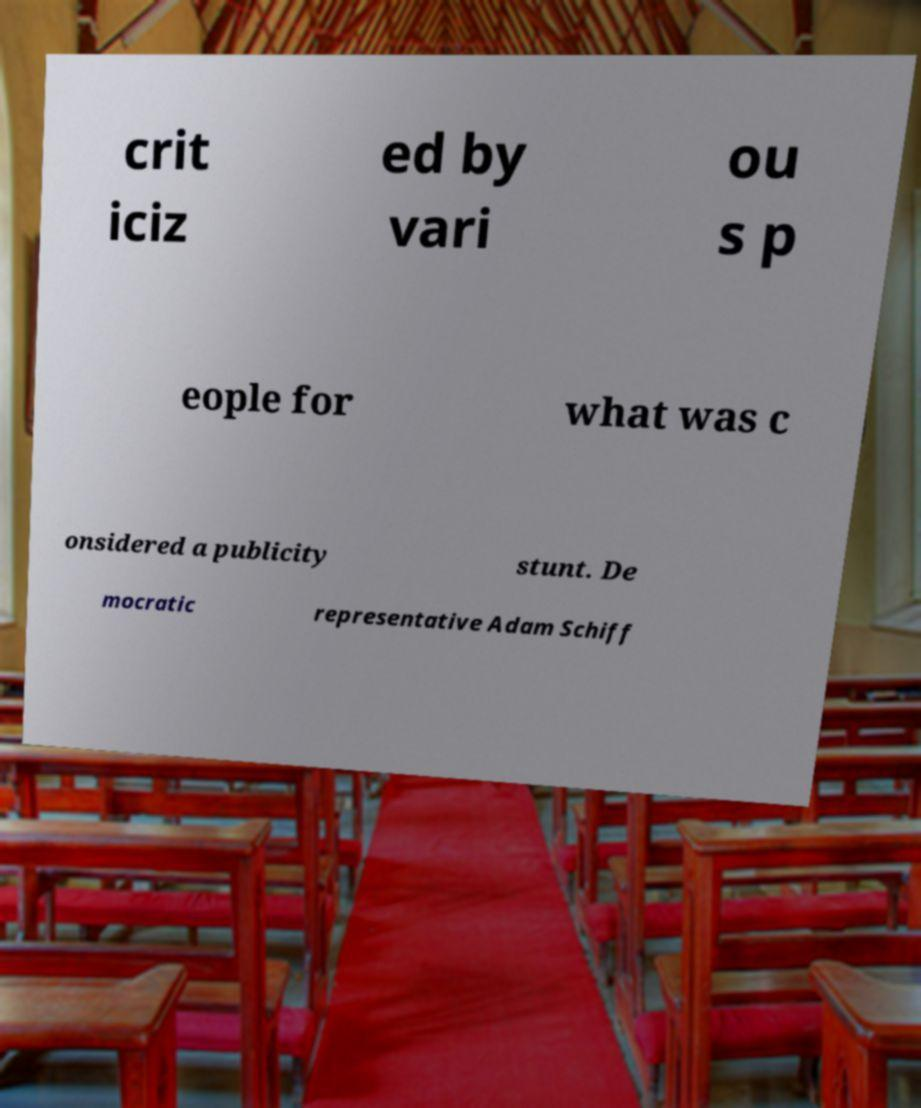Could you assist in decoding the text presented in this image and type it out clearly? crit iciz ed by vari ou s p eople for what was c onsidered a publicity stunt. De mocratic representative Adam Schiff 